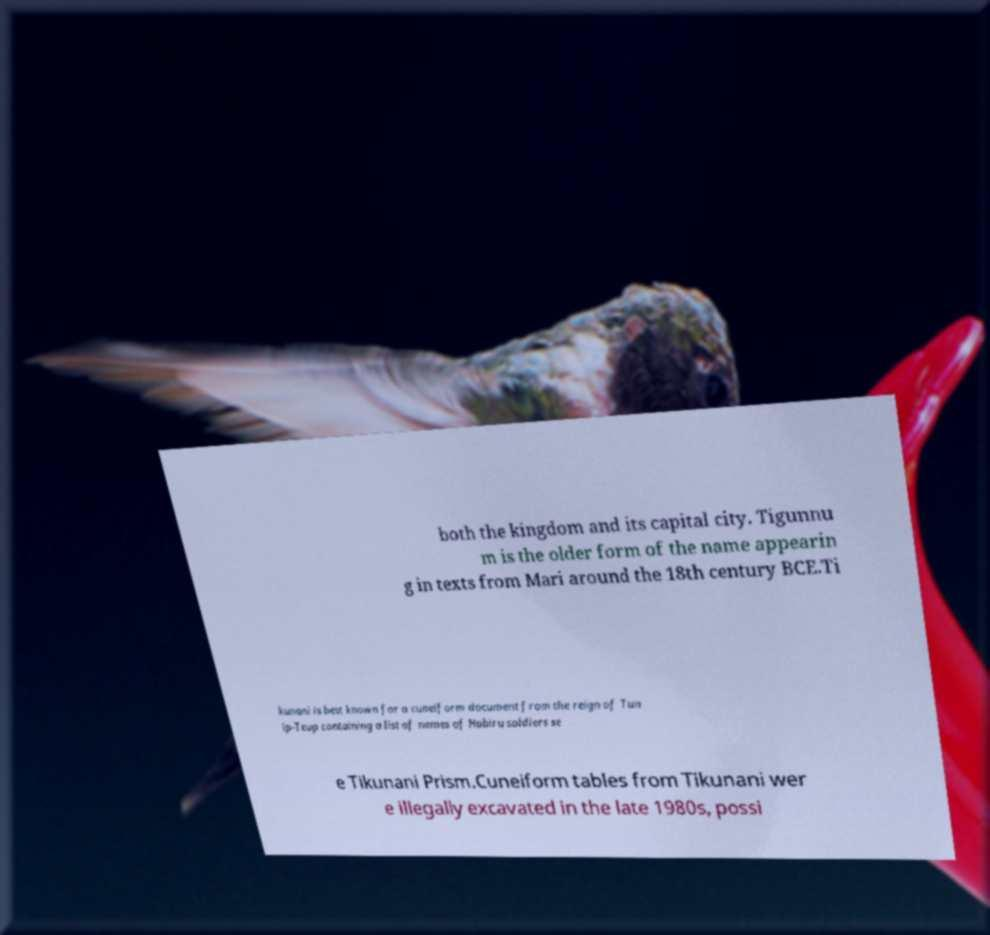Please identify and transcribe the text found in this image. both the kingdom and its capital city. Tigunnu m is the older form of the name appearin g in texts from Mari around the 18th century BCE.Ti kunani is best known for a cuneiform document from the reign of Tun ip-Teup containing a list of names of Habiru soldiers se e Tikunani Prism.Cuneiform tables from Tikunani wer e illegally excavated in the late 1980s, possi 